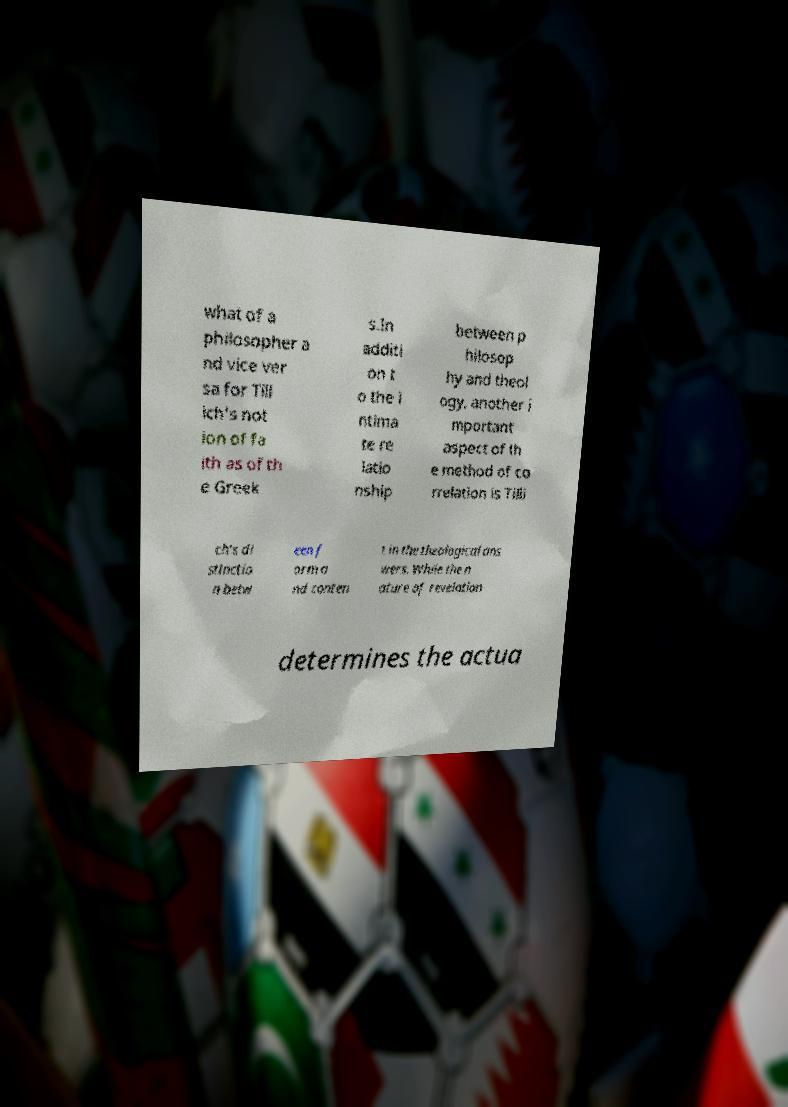Can you accurately transcribe the text from the provided image for me? what of a philosopher a nd vice ver sa for Till ich's not ion of fa ith as of th e Greek s.In additi on t o the i ntima te re latio nship between p hilosop hy and theol ogy, another i mportant aspect of th e method of co rrelation is Tilli ch's di stinctio n betw een f orm a nd conten t in the theological ans wers. While the n ature of revelation determines the actua 